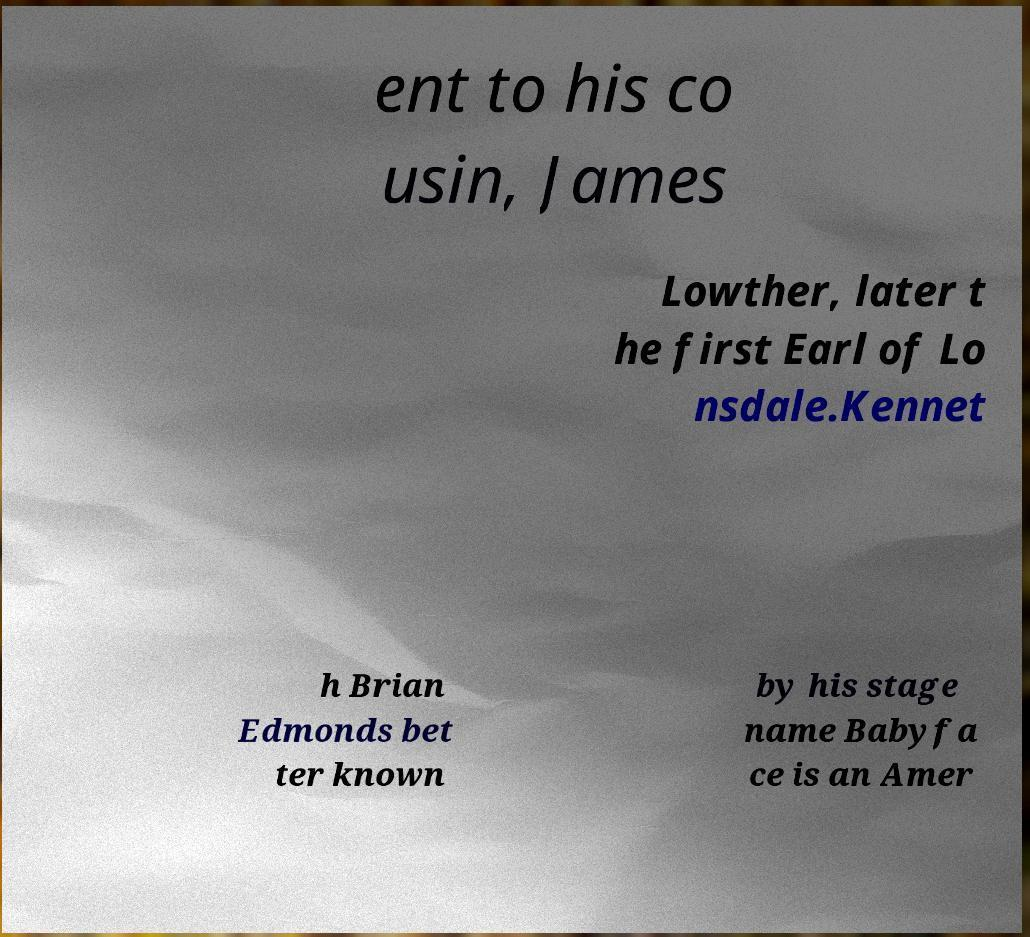What messages or text are displayed in this image? I need them in a readable, typed format. ent to his co usin, James Lowther, later t he first Earl of Lo nsdale.Kennet h Brian Edmonds bet ter known by his stage name Babyfa ce is an Amer 